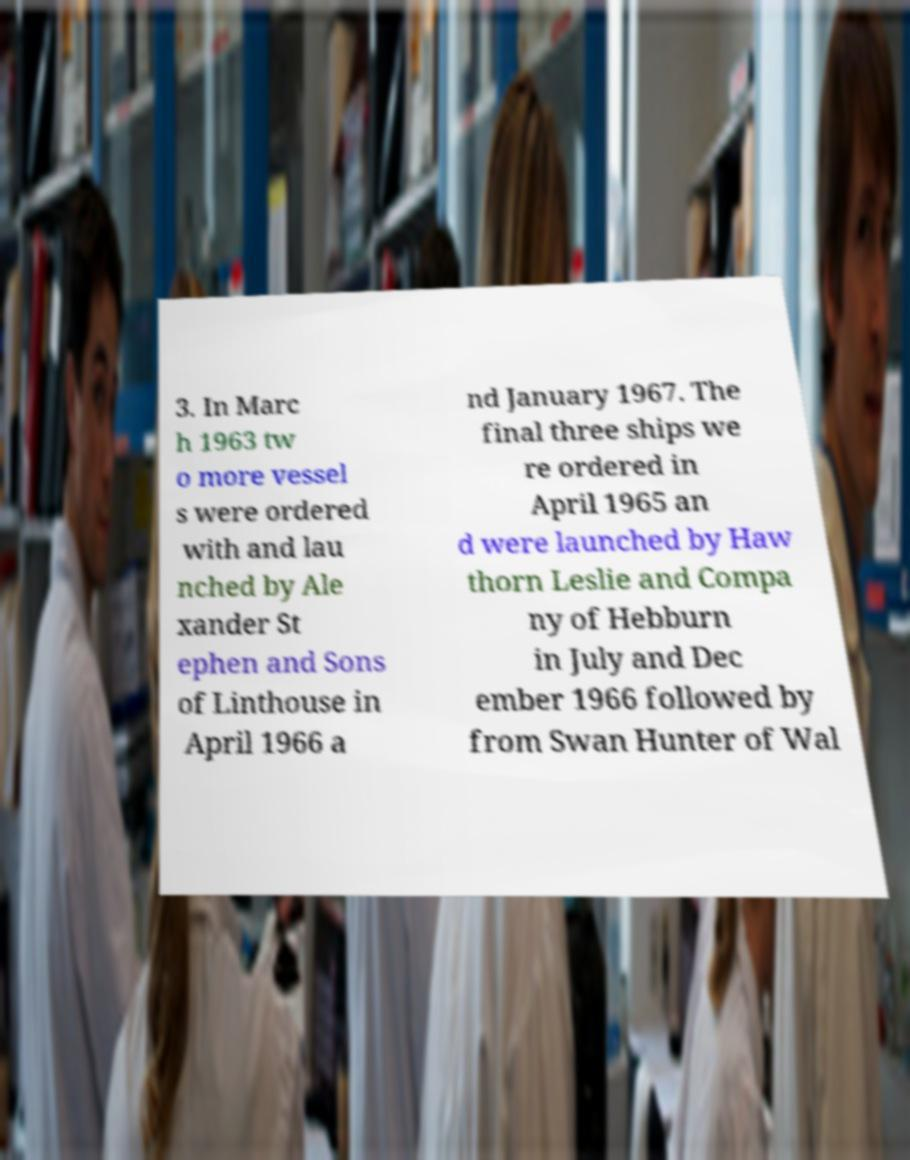There's text embedded in this image that I need extracted. Can you transcribe it verbatim? 3. In Marc h 1963 tw o more vessel s were ordered with and lau nched by Ale xander St ephen and Sons of Linthouse in April 1966 a nd January 1967. The final three ships we re ordered in April 1965 an d were launched by Haw thorn Leslie and Compa ny of Hebburn in July and Dec ember 1966 followed by from Swan Hunter of Wal 